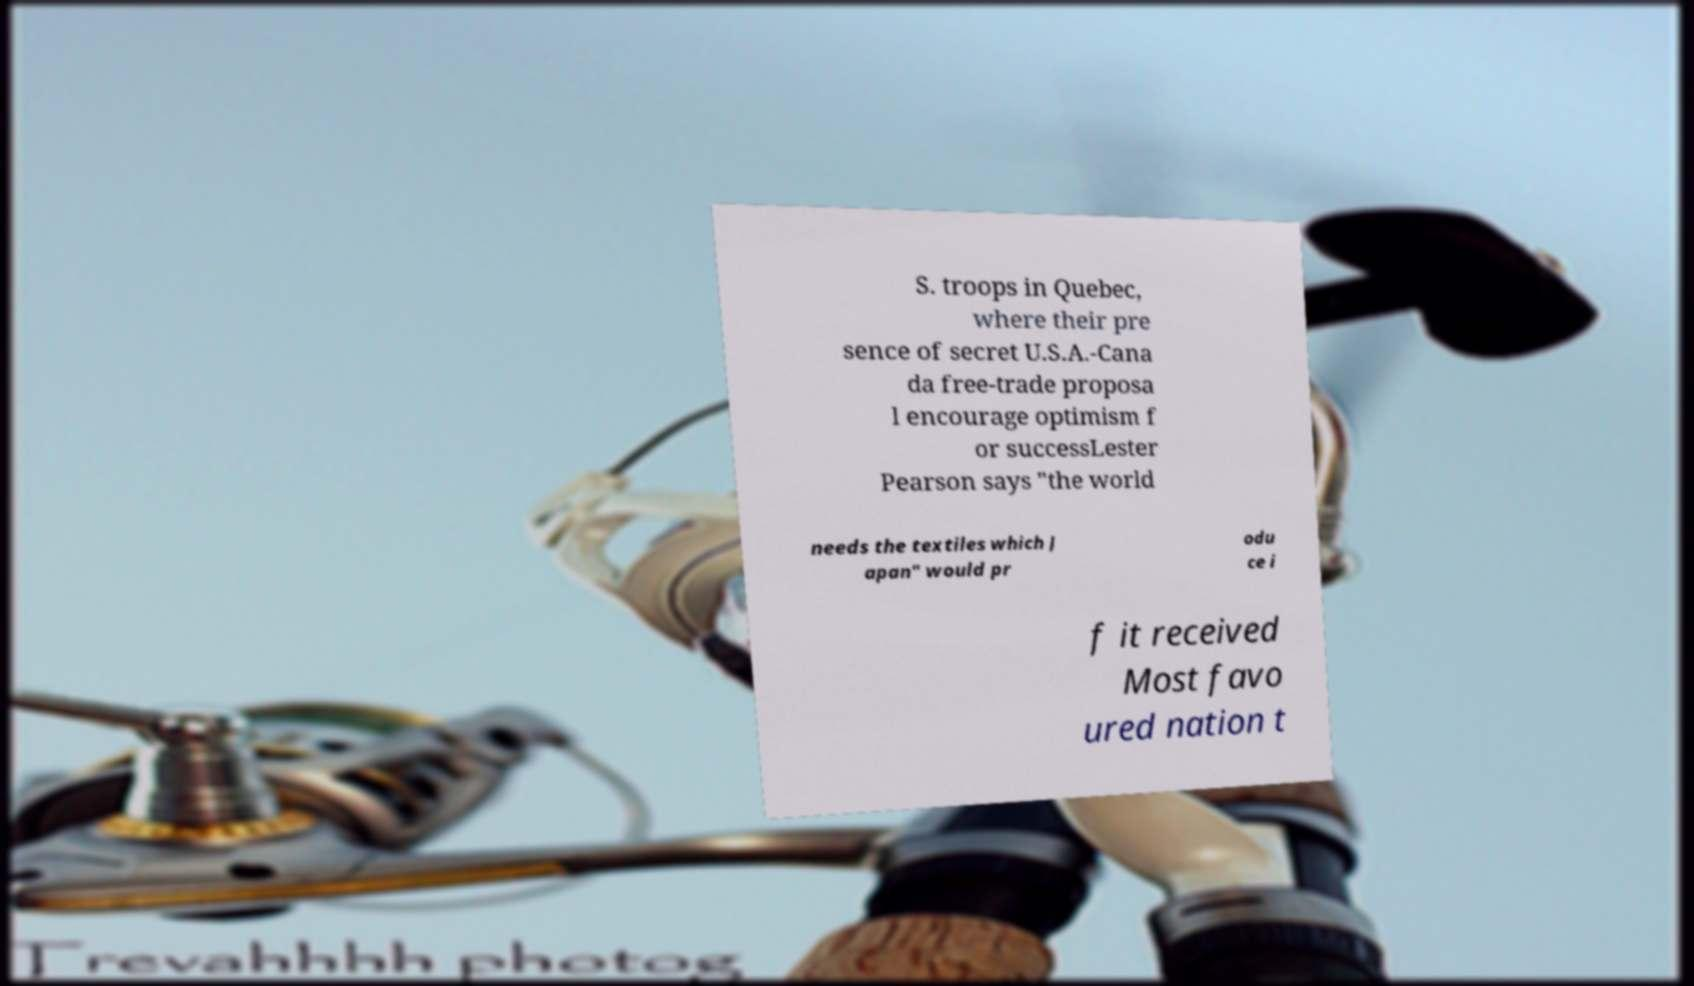There's text embedded in this image that I need extracted. Can you transcribe it verbatim? S. troops in Quebec, where their pre sence of secret U.S.A.-Cana da free-trade proposa l encourage optimism f or successLester Pearson says "the world needs the textiles which J apan" would pr odu ce i f it received Most favo ured nation t 